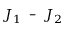<formula> <loc_0><loc_0><loc_500><loc_500>{ { J } _ { 1 } } - { { J } _ { 2 } }</formula> 